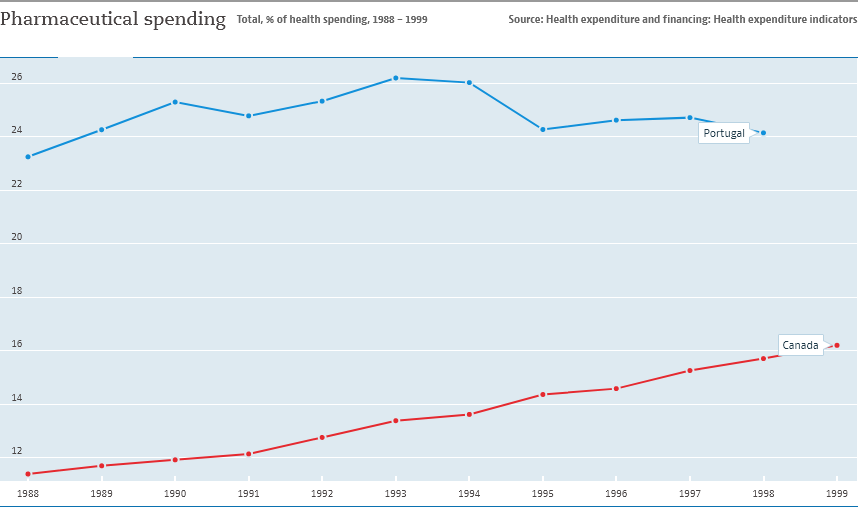Indicate a few pertinent items in this graphic. In 1999, Canada recorded the highest level of pharmaceutical spending. The country represented by the blue color line is Portugal. 